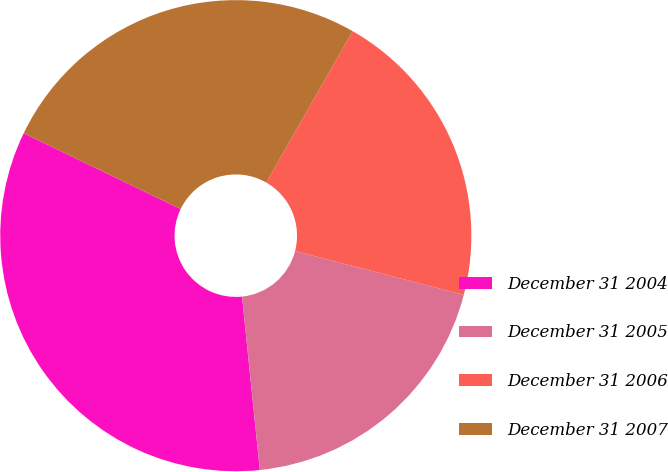Convert chart. <chart><loc_0><loc_0><loc_500><loc_500><pie_chart><fcel>December 31 2004<fcel>December 31 2005<fcel>December 31 2006<fcel>December 31 2007<nl><fcel>33.79%<fcel>19.33%<fcel>20.78%<fcel>26.1%<nl></chart> 